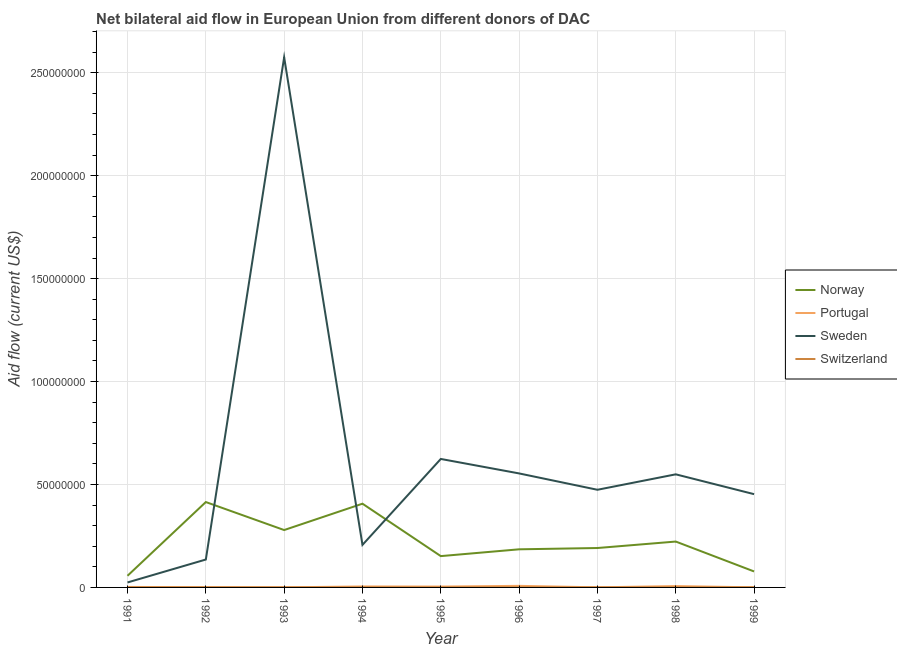Is the number of lines equal to the number of legend labels?
Offer a terse response. Yes. What is the amount of aid given by sweden in 1998?
Provide a short and direct response. 5.49e+07. Across all years, what is the maximum amount of aid given by switzerland?
Offer a terse response. 9.00e+04. Across all years, what is the minimum amount of aid given by norway?
Give a very brief answer. 5.65e+06. What is the total amount of aid given by sweden in the graph?
Your answer should be very brief. 5.60e+08. What is the difference between the amount of aid given by sweden in 1992 and that in 1993?
Provide a succinct answer. -2.44e+08. What is the difference between the amount of aid given by portugal in 1999 and the amount of aid given by norway in 1995?
Offer a very short reply. -1.52e+07. What is the average amount of aid given by portugal per year?
Offer a very short reply. 3.13e+05. In the year 1993, what is the difference between the amount of aid given by norway and amount of aid given by switzerland?
Offer a very short reply. 2.78e+07. In how many years, is the amount of aid given by switzerland greater than 170000000 US$?
Keep it short and to the point. 0. What is the ratio of the amount of aid given by switzerland in 1995 to that in 1998?
Make the answer very short. 0.57. Is the amount of aid given by norway in 1994 less than that in 1998?
Your response must be concise. No. What is the difference between the highest and the second highest amount of aid given by switzerland?
Offer a very short reply. 2.00e+04. What is the difference between the highest and the lowest amount of aid given by switzerland?
Ensure brevity in your answer.  5.00e+04. In how many years, is the amount of aid given by norway greater than the average amount of aid given by norway taken over all years?
Ensure brevity in your answer.  4. Does the amount of aid given by norway monotonically increase over the years?
Provide a short and direct response. No. How many lines are there?
Offer a very short reply. 4. What is the difference between two consecutive major ticks on the Y-axis?
Keep it short and to the point. 5.00e+07. Are the values on the major ticks of Y-axis written in scientific E-notation?
Provide a succinct answer. No. Does the graph contain any zero values?
Provide a succinct answer. No. How many legend labels are there?
Your answer should be very brief. 4. What is the title of the graph?
Your response must be concise. Net bilateral aid flow in European Union from different donors of DAC. What is the Aid flow (current US$) in Norway in 1991?
Make the answer very short. 5.65e+06. What is the Aid flow (current US$) of Portugal in 1991?
Offer a terse response. 2.40e+05. What is the Aid flow (current US$) in Sweden in 1991?
Provide a succinct answer. 2.41e+06. What is the Aid flow (current US$) in Switzerland in 1991?
Your response must be concise. 7.00e+04. What is the Aid flow (current US$) in Norway in 1992?
Give a very brief answer. 4.15e+07. What is the Aid flow (current US$) of Sweden in 1992?
Make the answer very short. 1.36e+07. What is the Aid flow (current US$) in Norway in 1993?
Offer a very short reply. 2.79e+07. What is the Aid flow (current US$) of Sweden in 1993?
Offer a very short reply. 2.57e+08. What is the Aid flow (current US$) in Switzerland in 1993?
Offer a very short reply. 6.00e+04. What is the Aid flow (current US$) in Norway in 1994?
Provide a short and direct response. 4.07e+07. What is the Aid flow (current US$) in Sweden in 1994?
Keep it short and to the point. 2.07e+07. What is the Aid flow (current US$) in Norway in 1995?
Provide a succinct answer. 1.52e+07. What is the Aid flow (current US$) in Portugal in 1995?
Give a very brief answer. 4.20e+05. What is the Aid flow (current US$) in Sweden in 1995?
Your answer should be compact. 6.24e+07. What is the Aid flow (current US$) in Switzerland in 1995?
Your response must be concise. 4.00e+04. What is the Aid flow (current US$) of Norway in 1996?
Your answer should be compact. 1.85e+07. What is the Aid flow (current US$) of Portugal in 1996?
Your answer should be very brief. 7.70e+05. What is the Aid flow (current US$) of Sweden in 1996?
Offer a terse response. 5.54e+07. What is the Aid flow (current US$) in Norway in 1997?
Offer a terse response. 1.91e+07. What is the Aid flow (current US$) in Sweden in 1997?
Provide a short and direct response. 4.74e+07. What is the Aid flow (current US$) of Norway in 1998?
Provide a succinct answer. 2.23e+07. What is the Aid flow (current US$) of Portugal in 1998?
Keep it short and to the point. 6.60e+05. What is the Aid flow (current US$) in Sweden in 1998?
Offer a terse response. 5.49e+07. What is the Aid flow (current US$) in Switzerland in 1998?
Your answer should be compact. 7.00e+04. What is the Aid flow (current US$) in Norway in 1999?
Give a very brief answer. 7.76e+06. What is the Aid flow (current US$) of Sweden in 1999?
Your answer should be very brief. 4.53e+07. Across all years, what is the maximum Aid flow (current US$) in Norway?
Offer a terse response. 4.15e+07. Across all years, what is the maximum Aid flow (current US$) in Portugal?
Provide a short and direct response. 7.70e+05. Across all years, what is the maximum Aid flow (current US$) in Sweden?
Give a very brief answer. 2.57e+08. Across all years, what is the minimum Aid flow (current US$) of Norway?
Your answer should be compact. 5.65e+06. Across all years, what is the minimum Aid flow (current US$) of Portugal?
Your answer should be very brief. 4.00e+04. Across all years, what is the minimum Aid flow (current US$) in Sweden?
Your answer should be compact. 2.41e+06. Across all years, what is the minimum Aid flow (current US$) of Switzerland?
Offer a very short reply. 4.00e+04. What is the total Aid flow (current US$) of Norway in the graph?
Your response must be concise. 1.99e+08. What is the total Aid flow (current US$) of Portugal in the graph?
Give a very brief answer. 2.82e+06. What is the total Aid flow (current US$) of Sweden in the graph?
Offer a very short reply. 5.60e+08. What is the total Aid flow (current US$) in Switzerland in the graph?
Your response must be concise. 5.70e+05. What is the difference between the Aid flow (current US$) of Norway in 1991 and that in 1992?
Your response must be concise. -3.58e+07. What is the difference between the Aid flow (current US$) in Portugal in 1991 and that in 1992?
Your answer should be very brief. 1.20e+05. What is the difference between the Aid flow (current US$) of Sweden in 1991 and that in 1992?
Give a very brief answer. -1.11e+07. What is the difference between the Aid flow (current US$) in Switzerland in 1991 and that in 1992?
Your answer should be compact. 0. What is the difference between the Aid flow (current US$) of Norway in 1991 and that in 1993?
Make the answer very short. -2.22e+07. What is the difference between the Aid flow (current US$) in Sweden in 1991 and that in 1993?
Offer a very short reply. -2.55e+08. What is the difference between the Aid flow (current US$) in Norway in 1991 and that in 1994?
Your answer should be compact. -3.50e+07. What is the difference between the Aid flow (current US$) of Portugal in 1991 and that in 1994?
Your response must be concise. -2.30e+05. What is the difference between the Aid flow (current US$) of Sweden in 1991 and that in 1994?
Your answer should be compact. -1.82e+07. What is the difference between the Aid flow (current US$) in Switzerland in 1991 and that in 1994?
Provide a short and direct response. 2.00e+04. What is the difference between the Aid flow (current US$) of Norway in 1991 and that in 1995?
Make the answer very short. -9.56e+06. What is the difference between the Aid flow (current US$) of Portugal in 1991 and that in 1995?
Your answer should be very brief. -1.80e+05. What is the difference between the Aid flow (current US$) in Sweden in 1991 and that in 1995?
Make the answer very short. -6.00e+07. What is the difference between the Aid flow (current US$) in Switzerland in 1991 and that in 1995?
Your answer should be very brief. 3.00e+04. What is the difference between the Aid flow (current US$) in Norway in 1991 and that in 1996?
Ensure brevity in your answer.  -1.29e+07. What is the difference between the Aid flow (current US$) in Portugal in 1991 and that in 1996?
Provide a succinct answer. -5.30e+05. What is the difference between the Aid flow (current US$) of Sweden in 1991 and that in 1996?
Your answer should be compact. -5.30e+07. What is the difference between the Aid flow (current US$) in Norway in 1991 and that in 1997?
Ensure brevity in your answer.  -1.35e+07. What is the difference between the Aid flow (current US$) in Portugal in 1991 and that in 1997?
Provide a succinct answer. 1.90e+05. What is the difference between the Aid flow (current US$) of Sweden in 1991 and that in 1997?
Ensure brevity in your answer.  -4.50e+07. What is the difference between the Aid flow (current US$) in Switzerland in 1991 and that in 1997?
Provide a short and direct response. 10000. What is the difference between the Aid flow (current US$) in Norway in 1991 and that in 1998?
Give a very brief answer. -1.66e+07. What is the difference between the Aid flow (current US$) of Portugal in 1991 and that in 1998?
Make the answer very short. -4.20e+05. What is the difference between the Aid flow (current US$) in Sweden in 1991 and that in 1998?
Offer a very short reply. -5.25e+07. What is the difference between the Aid flow (current US$) of Norway in 1991 and that in 1999?
Provide a succinct answer. -2.11e+06. What is the difference between the Aid flow (current US$) in Sweden in 1991 and that in 1999?
Offer a terse response. -4.29e+07. What is the difference between the Aid flow (current US$) of Norway in 1992 and that in 1993?
Your response must be concise. 1.36e+07. What is the difference between the Aid flow (current US$) in Sweden in 1992 and that in 1993?
Offer a very short reply. -2.44e+08. What is the difference between the Aid flow (current US$) of Switzerland in 1992 and that in 1993?
Offer a very short reply. 10000. What is the difference between the Aid flow (current US$) of Portugal in 1992 and that in 1994?
Keep it short and to the point. -3.50e+05. What is the difference between the Aid flow (current US$) of Sweden in 1992 and that in 1994?
Provide a succinct answer. -7.11e+06. What is the difference between the Aid flow (current US$) of Switzerland in 1992 and that in 1994?
Your answer should be very brief. 2.00e+04. What is the difference between the Aid flow (current US$) of Norway in 1992 and that in 1995?
Offer a very short reply. 2.63e+07. What is the difference between the Aid flow (current US$) of Sweden in 1992 and that in 1995?
Offer a terse response. -4.88e+07. What is the difference between the Aid flow (current US$) of Switzerland in 1992 and that in 1995?
Your response must be concise. 3.00e+04. What is the difference between the Aid flow (current US$) of Norway in 1992 and that in 1996?
Keep it short and to the point. 2.30e+07. What is the difference between the Aid flow (current US$) of Portugal in 1992 and that in 1996?
Ensure brevity in your answer.  -6.50e+05. What is the difference between the Aid flow (current US$) of Sweden in 1992 and that in 1996?
Your answer should be very brief. -4.18e+07. What is the difference between the Aid flow (current US$) in Norway in 1992 and that in 1997?
Keep it short and to the point. 2.23e+07. What is the difference between the Aid flow (current US$) in Sweden in 1992 and that in 1997?
Ensure brevity in your answer.  -3.39e+07. What is the difference between the Aid flow (current US$) in Switzerland in 1992 and that in 1997?
Provide a short and direct response. 10000. What is the difference between the Aid flow (current US$) in Norway in 1992 and that in 1998?
Provide a short and direct response. 1.92e+07. What is the difference between the Aid flow (current US$) in Portugal in 1992 and that in 1998?
Your response must be concise. -5.40e+05. What is the difference between the Aid flow (current US$) in Sweden in 1992 and that in 1998?
Offer a terse response. -4.14e+07. What is the difference between the Aid flow (current US$) of Switzerland in 1992 and that in 1998?
Offer a very short reply. 0. What is the difference between the Aid flow (current US$) in Norway in 1992 and that in 1999?
Ensure brevity in your answer.  3.37e+07. What is the difference between the Aid flow (current US$) of Portugal in 1992 and that in 1999?
Make the answer very short. 7.00e+04. What is the difference between the Aid flow (current US$) in Sweden in 1992 and that in 1999?
Your answer should be compact. -3.18e+07. What is the difference between the Aid flow (current US$) in Switzerland in 1992 and that in 1999?
Provide a succinct answer. -2.00e+04. What is the difference between the Aid flow (current US$) in Norway in 1993 and that in 1994?
Your answer should be compact. -1.28e+07. What is the difference between the Aid flow (current US$) of Portugal in 1993 and that in 1994?
Provide a short and direct response. -4.30e+05. What is the difference between the Aid flow (current US$) of Sweden in 1993 and that in 1994?
Your answer should be compact. 2.37e+08. What is the difference between the Aid flow (current US$) of Norway in 1993 and that in 1995?
Keep it short and to the point. 1.27e+07. What is the difference between the Aid flow (current US$) of Portugal in 1993 and that in 1995?
Provide a short and direct response. -3.80e+05. What is the difference between the Aid flow (current US$) of Sweden in 1993 and that in 1995?
Keep it short and to the point. 1.95e+08. What is the difference between the Aid flow (current US$) of Switzerland in 1993 and that in 1995?
Provide a succinct answer. 2.00e+04. What is the difference between the Aid flow (current US$) in Norway in 1993 and that in 1996?
Your answer should be compact. 9.36e+06. What is the difference between the Aid flow (current US$) in Portugal in 1993 and that in 1996?
Offer a very short reply. -7.30e+05. What is the difference between the Aid flow (current US$) in Sweden in 1993 and that in 1996?
Keep it short and to the point. 2.02e+08. What is the difference between the Aid flow (current US$) in Norway in 1993 and that in 1997?
Your answer should be compact. 8.73e+06. What is the difference between the Aid flow (current US$) in Sweden in 1993 and that in 1997?
Give a very brief answer. 2.10e+08. What is the difference between the Aid flow (current US$) of Switzerland in 1993 and that in 1997?
Give a very brief answer. 0. What is the difference between the Aid flow (current US$) in Norway in 1993 and that in 1998?
Your answer should be very brief. 5.59e+06. What is the difference between the Aid flow (current US$) in Portugal in 1993 and that in 1998?
Your answer should be very brief. -6.20e+05. What is the difference between the Aid flow (current US$) in Sweden in 1993 and that in 1998?
Your answer should be compact. 2.03e+08. What is the difference between the Aid flow (current US$) of Norway in 1993 and that in 1999?
Give a very brief answer. 2.01e+07. What is the difference between the Aid flow (current US$) in Sweden in 1993 and that in 1999?
Offer a very short reply. 2.12e+08. What is the difference between the Aid flow (current US$) of Norway in 1994 and that in 1995?
Offer a very short reply. 2.55e+07. What is the difference between the Aid flow (current US$) of Sweden in 1994 and that in 1995?
Keep it short and to the point. -4.17e+07. What is the difference between the Aid flow (current US$) of Switzerland in 1994 and that in 1995?
Offer a very short reply. 10000. What is the difference between the Aid flow (current US$) of Norway in 1994 and that in 1996?
Ensure brevity in your answer.  2.22e+07. What is the difference between the Aid flow (current US$) of Portugal in 1994 and that in 1996?
Give a very brief answer. -3.00e+05. What is the difference between the Aid flow (current US$) of Sweden in 1994 and that in 1996?
Give a very brief answer. -3.47e+07. What is the difference between the Aid flow (current US$) of Norway in 1994 and that in 1997?
Make the answer very short. 2.15e+07. What is the difference between the Aid flow (current US$) of Sweden in 1994 and that in 1997?
Make the answer very short. -2.68e+07. What is the difference between the Aid flow (current US$) of Norway in 1994 and that in 1998?
Offer a terse response. 1.84e+07. What is the difference between the Aid flow (current US$) of Portugal in 1994 and that in 1998?
Provide a short and direct response. -1.90e+05. What is the difference between the Aid flow (current US$) in Sweden in 1994 and that in 1998?
Offer a terse response. -3.43e+07. What is the difference between the Aid flow (current US$) of Norway in 1994 and that in 1999?
Your response must be concise. 3.29e+07. What is the difference between the Aid flow (current US$) of Sweden in 1994 and that in 1999?
Provide a short and direct response. -2.46e+07. What is the difference between the Aid flow (current US$) in Switzerland in 1994 and that in 1999?
Provide a succinct answer. -4.00e+04. What is the difference between the Aid flow (current US$) in Norway in 1995 and that in 1996?
Offer a terse response. -3.30e+06. What is the difference between the Aid flow (current US$) of Portugal in 1995 and that in 1996?
Offer a very short reply. -3.50e+05. What is the difference between the Aid flow (current US$) of Sweden in 1995 and that in 1996?
Your answer should be compact. 7.03e+06. What is the difference between the Aid flow (current US$) of Switzerland in 1995 and that in 1996?
Keep it short and to the point. -2.00e+04. What is the difference between the Aid flow (current US$) in Norway in 1995 and that in 1997?
Keep it short and to the point. -3.93e+06. What is the difference between the Aid flow (current US$) in Sweden in 1995 and that in 1997?
Ensure brevity in your answer.  1.50e+07. What is the difference between the Aid flow (current US$) of Norway in 1995 and that in 1998?
Provide a succinct answer. -7.07e+06. What is the difference between the Aid flow (current US$) of Sweden in 1995 and that in 1998?
Give a very brief answer. 7.47e+06. What is the difference between the Aid flow (current US$) of Switzerland in 1995 and that in 1998?
Your answer should be very brief. -3.00e+04. What is the difference between the Aid flow (current US$) of Norway in 1995 and that in 1999?
Your answer should be compact. 7.45e+06. What is the difference between the Aid flow (current US$) of Sweden in 1995 and that in 1999?
Your answer should be compact. 1.71e+07. What is the difference between the Aid flow (current US$) of Switzerland in 1995 and that in 1999?
Keep it short and to the point. -5.00e+04. What is the difference between the Aid flow (current US$) in Norway in 1996 and that in 1997?
Your answer should be very brief. -6.30e+05. What is the difference between the Aid flow (current US$) in Portugal in 1996 and that in 1997?
Provide a succinct answer. 7.20e+05. What is the difference between the Aid flow (current US$) in Sweden in 1996 and that in 1997?
Give a very brief answer. 7.94e+06. What is the difference between the Aid flow (current US$) in Norway in 1996 and that in 1998?
Your answer should be compact. -3.77e+06. What is the difference between the Aid flow (current US$) in Portugal in 1996 and that in 1998?
Make the answer very short. 1.10e+05. What is the difference between the Aid flow (current US$) in Switzerland in 1996 and that in 1998?
Your answer should be very brief. -10000. What is the difference between the Aid flow (current US$) in Norway in 1996 and that in 1999?
Give a very brief answer. 1.08e+07. What is the difference between the Aid flow (current US$) of Portugal in 1996 and that in 1999?
Ensure brevity in your answer.  7.20e+05. What is the difference between the Aid flow (current US$) in Sweden in 1996 and that in 1999?
Offer a terse response. 1.01e+07. What is the difference between the Aid flow (current US$) of Switzerland in 1996 and that in 1999?
Make the answer very short. -3.00e+04. What is the difference between the Aid flow (current US$) of Norway in 1997 and that in 1998?
Provide a short and direct response. -3.14e+06. What is the difference between the Aid flow (current US$) in Portugal in 1997 and that in 1998?
Ensure brevity in your answer.  -6.10e+05. What is the difference between the Aid flow (current US$) of Sweden in 1997 and that in 1998?
Your answer should be very brief. -7.50e+06. What is the difference between the Aid flow (current US$) of Switzerland in 1997 and that in 1998?
Give a very brief answer. -10000. What is the difference between the Aid flow (current US$) of Norway in 1997 and that in 1999?
Keep it short and to the point. 1.14e+07. What is the difference between the Aid flow (current US$) of Portugal in 1997 and that in 1999?
Give a very brief answer. 0. What is the difference between the Aid flow (current US$) of Sweden in 1997 and that in 1999?
Your answer should be very brief. 2.13e+06. What is the difference between the Aid flow (current US$) in Switzerland in 1997 and that in 1999?
Give a very brief answer. -3.00e+04. What is the difference between the Aid flow (current US$) in Norway in 1998 and that in 1999?
Make the answer very short. 1.45e+07. What is the difference between the Aid flow (current US$) of Portugal in 1998 and that in 1999?
Offer a terse response. 6.10e+05. What is the difference between the Aid flow (current US$) of Sweden in 1998 and that in 1999?
Provide a succinct answer. 9.63e+06. What is the difference between the Aid flow (current US$) of Switzerland in 1998 and that in 1999?
Offer a very short reply. -2.00e+04. What is the difference between the Aid flow (current US$) of Norway in 1991 and the Aid flow (current US$) of Portugal in 1992?
Your answer should be compact. 5.53e+06. What is the difference between the Aid flow (current US$) of Norway in 1991 and the Aid flow (current US$) of Sweden in 1992?
Make the answer very short. -7.90e+06. What is the difference between the Aid flow (current US$) of Norway in 1991 and the Aid flow (current US$) of Switzerland in 1992?
Provide a short and direct response. 5.58e+06. What is the difference between the Aid flow (current US$) in Portugal in 1991 and the Aid flow (current US$) in Sweden in 1992?
Provide a short and direct response. -1.33e+07. What is the difference between the Aid flow (current US$) in Portugal in 1991 and the Aid flow (current US$) in Switzerland in 1992?
Offer a terse response. 1.70e+05. What is the difference between the Aid flow (current US$) of Sweden in 1991 and the Aid flow (current US$) of Switzerland in 1992?
Make the answer very short. 2.34e+06. What is the difference between the Aid flow (current US$) in Norway in 1991 and the Aid flow (current US$) in Portugal in 1993?
Your answer should be compact. 5.61e+06. What is the difference between the Aid flow (current US$) of Norway in 1991 and the Aid flow (current US$) of Sweden in 1993?
Keep it short and to the point. -2.52e+08. What is the difference between the Aid flow (current US$) in Norway in 1991 and the Aid flow (current US$) in Switzerland in 1993?
Keep it short and to the point. 5.59e+06. What is the difference between the Aid flow (current US$) of Portugal in 1991 and the Aid flow (current US$) of Sweden in 1993?
Provide a succinct answer. -2.57e+08. What is the difference between the Aid flow (current US$) of Sweden in 1991 and the Aid flow (current US$) of Switzerland in 1993?
Your response must be concise. 2.35e+06. What is the difference between the Aid flow (current US$) of Norway in 1991 and the Aid flow (current US$) of Portugal in 1994?
Make the answer very short. 5.18e+06. What is the difference between the Aid flow (current US$) of Norway in 1991 and the Aid flow (current US$) of Sweden in 1994?
Provide a succinct answer. -1.50e+07. What is the difference between the Aid flow (current US$) in Norway in 1991 and the Aid flow (current US$) in Switzerland in 1994?
Ensure brevity in your answer.  5.60e+06. What is the difference between the Aid flow (current US$) in Portugal in 1991 and the Aid flow (current US$) in Sweden in 1994?
Make the answer very short. -2.04e+07. What is the difference between the Aid flow (current US$) in Sweden in 1991 and the Aid flow (current US$) in Switzerland in 1994?
Your response must be concise. 2.36e+06. What is the difference between the Aid flow (current US$) of Norway in 1991 and the Aid flow (current US$) of Portugal in 1995?
Give a very brief answer. 5.23e+06. What is the difference between the Aid flow (current US$) of Norway in 1991 and the Aid flow (current US$) of Sweden in 1995?
Offer a very short reply. -5.68e+07. What is the difference between the Aid flow (current US$) in Norway in 1991 and the Aid flow (current US$) in Switzerland in 1995?
Offer a very short reply. 5.61e+06. What is the difference between the Aid flow (current US$) in Portugal in 1991 and the Aid flow (current US$) in Sweden in 1995?
Offer a terse response. -6.22e+07. What is the difference between the Aid flow (current US$) of Sweden in 1991 and the Aid flow (current US$) of Switzerland in 1995?
Offer a very short reply. 2.37e+06. What is the difference between the Aid flow (current US$) in Norway in 1991 and the Aid flow (current US$) in Portugal in 1996?
Make the answer very short. 4.88e+06. What is the difference between the Aid flow (current US$) of Norway in 1991 and the Aid flow (current US$) of Sweden in 1996?
Your answer should be very brief. -4.97e+07. What is the difference between the Aid flow (current US$) in Norway in 1991 and the Aid flow (current US$) in Switzerland in 1996?
Ensure brevity in your answer.  5.59e+06. What is the difference between the Aid flow (current US$) of Portugal in 1991 and the Aid flow (current US$) of Sweden in 1996?
Offer a very short reply. -5.51e+07. What is the difference between the Aid flow (current US$) of Portugal in 1991 and the Aid flow (current US$) of Switzerland in 1996?
Provide a succinct answer. 1.80e+05. What is the difference between the Aid flow (current US$) of Sweden in 1991 and the Aid flow (current US$) of Switzerland in 1996?
Offer a very short reply. 2.35e+06. What is the difference between the Aid flow (current US$) of Norway in 1991 and the Aid flow (current US$) of Portugal in 1997?
Offer a terse response. 5.60e+06. What is the difference between the Aid flow (current US$) of Norway in 1991 and the Aid flow (current US$) of Sweden in 1997?
Ensure brevity in your answer.  -4.18e+07. What is the difference between the Aid flow (current US$) in Norway in 1991 and the Aid flow (current US$) in Switzerland in 1997?
Your response must be concise. 5.59e+06. What is the difference between the Aid flow (current US$) of Portugal in 1991 and the Aid flow (current US$) of Sweden in 1997?
Offer a very short reply. -4.72e+07. What is the difference between the Aid flow (current US$) in Sweden in 1991 and the Aid flow (current US$) in Switzerland in 1997?
Offer a terse response. 2.35e+06. What is the difference between the Aid flow (current US$) of Norway in 1991 and the Aid flow (current US$) of Portugal in 1998?
Give a very brief answer. 4.99e+06. What is the difference between the Aid flow (current US$) in Norway in 1991 and the Aid flow (current US$) in Sweden in 1998?
Offer a terse response. -4.93e+07. What is the difference between the Aid flow (current US$) in Norway in 1991 and the Aid flow (current US$) in Switzerland in 1998?
Your answer should be very brief. 5.58e+06. What is the difference between the Aid flow (current US$) of Portugal in 1991 and the Aid flow (current US$) of Sweden in 1998?
Your answer should be compact. -5.47e+07. What is the difference between the Aid flow (current US$) in Sweden in 1991 and the Aid flow (current US$) in Switzerland in 1998?
Provide a short and direct response. 2.34e+06. What is the difference between the Aid flow (current US$) of Norway in 1991 and the Aid flow (current US$) of Portugal in 1999?
Your response must be concise. 5.60e+06. What is the difference between the Aid flow (current US$) in Norway in 1991 and the Aid flow (current US$) in Sweden in 1999?
Keep it short and to the point. -3.96e+07. What is the difference between the Aid flow (current US$) of Norway in 1991 and the Aid flow (current US$) of Switzerland in 1999?
Your response must be concise. 5.56e+06. What is the difference between the Aid flow (current US$) in Portugal in 1991 and the Aid flow (current US$) in Sweden in 1999?
Provide a short and direct response. -4.51e+07. What is the difference between the Aid flow (current US$) in Portugal in 1991 and the Aid flow (current US$) in Switzerland in 1999?
Ensure brevity in your answer.  1.50e+05. What is the difference between the Aid flow (current US$) of Sweden in 1991 and the Aid flow (current US$) of Switzerland in 1999?
Offer a terse response. 2.32e+06. What is the difference between the Aid flow (current US$) in Norway in 1992 and the Aid flow (current US$) in Portugal in 1993?
Your answer should be compact. 4.14e+07. What is the difference between the Aid flow (current US$) in Norway in 1992 and the Aid flow (current US$) in Sweden in 1993?
Keep it short and to the point. -2.16e+08. What is the difference between the Aid flow (current US$) of Norway in 1992 and the Aid flow (current US$) of Switzerland in 1993?
Your response must be concise. 4.14e+07. What is the difference between the Aid flow (current US$) of Portugal in 1992 and the Aid flow (current US$) of Sweden in 1993?
Provide a short and direct response. -2.57e+08. What is the difference between the Aid flow (current US$) in Portugal in 1992 and the Aid flow (current US$) in Switzerland in 1993?
Give a very brief answer. 6.00e+04. What is the difference between the Aid flow (current US$) in Sweden in 1992 and the Aid flow (current US$) in Switzerland in 1993?
Keep it short and to the point. 1.35e+07. What is the difference between the Aid flow (current US$) of Norway in 1992 and the Aid flow (current US$) of Portugal in 1994?
Offer a very short reply. 4.10e+07. What is the difference between the Aid flow (current US$) in Norway in 1992 and the Aid flow (current US$) in Sweden in 1994?
Offer a very short reply. 2.08e+07. What is the difference between the Aid flow (current US$) in Norway in 1992 and the Aid flow (current US$) in Switzerland in 1994?
Offer a very short reply. 4.14e+07. What is the difference between the Aid flow (current US$) in Portugal in 1992 and the Aid flow (current US$) in Sweden in 1994?
Keep it short and to the point. -2.05e+07. What is the difference between the Aid flow (current US$) in Sweden in 1992 and the Aid flow (current US$) in Switzerland in 1994?
Offer a very short reply. 1.35e+07. What is the difference between the Aid flow (current US$) of Norway in 1992 and the Aid flow (current US$) of Portugal in 1995?
Offer a very short reply. 4.10e+07. What is the difference between the Aid flow (current US$) in Norway in 1992 and the Aid flow (current US$) in Sweden in 1995?
Provide a succinct answer. -2.09e+07. What is the difference between the Aid flow (current US$) in Norway in 1992 and the Aid flow (current US$) in Switzerland in 1995?
Your response must be concise. 4.14e+07. What is the difference between the Aid flow (current US$) of Portugal in 1992 and the Aid flow (current US$) of Sweden in 1995?
Your answer should be compact. -6.23e+07. What is the difference between the Aid flow (current US$) of Portugal in 1992 and the Aid flow (current US$) of Switzerland in 1995?
Offer a terse response. 8.00e+04. What is the difference between the Aid flow (current US$) in Sweden in 1992 and the Aid flow (current US$) in Switzerland in 1995?
Offer a terse response. 1.35e+07. What is the difference between the Aid flow (current US$) of Norway in 1992 and the Aid flow (current US$) of Portugal in 1996?
Your response must be concise. 4.07e+07. What is the difference between the Aid flow (current US$) of Norway in 1992 and the Aid flow (current US$) of Sweden in 1996?
Provide a succinct answer. -1.39e+07. What is the difference between the Aid flow (current US$) in Norway in 1992 and the Aid flow (current US$) in Switzerland in 1996?
Provide a short and direct response. 4.14e+07. What is the difference between the Aid flow (current US$) in Portugal in 1992 and the Aid flow (current US$) in Sweden in 1996?
Offer a terse response. -5.52e+07. What is the difference between the Aid flow (current US$) in Portugal in 1992 and the Aid flow (current US$) in Switzerland in 1996?
Offer a terse response. 6.00e+04. What is the difference between the Aid flow (current US$) in Sweden in 1992 and the Aid flow (current US$) in Switzerland in 1996?
Your answer should be compact. 1.35e+07. What is the difference between the Aid flow (current US$) of Norway in 1992 and the Aid flow (current US$) of Portugal in 1997?
Offer a very short reply. 4.14e+07. What is the difference between the Aid flow (current US$) in Norway in 1992 and the Aid flow (current US$) in Sweden in 1997?
Keep it short and to the point. -5.96e+06. What is the difference between the Aid flow (current US$) of Norway in 1992 and the Aid flow (current US$) of Switzerland in 1997?
Make the answer very short. 4.14e+07. What is the difference between the Aid flow (current US$) of Portugal in 1992 and the Aid flow (current US$) of Sweden in 1997?
Offer a very short reply. -4.73e+07. What is the difference between the Aid flow (current US$) in Portugal in 1992 and the Aid flow (current US$) in Switzerland in 1997?
Provide a succinct answer. 6.00e+04. What is the difference between the Aid flow (current US$) of Sweden in 1992 and the Aid flow (current US$) of Switzerland in 1997?
Give a very brief answer. 1.35e+07. What is the difference between the Aid flow (current US$) of Norway in 1992 and the Aid flow (current US$) of Portugal in 1998?
Offer a very short reply. 4.08e+07. What is the difference between the Aid flow (current US$) in Norway in 1992 and the Aid flow (current US$) in Sweden in 1998?
Make the answer very short. -1.35e+07. What is the difference between the Aid flow (current US$) of Norway in 1992 and the Aid flow (current US$) of Switzerland in 1998?
Offer a terse response. 4.14e+07. What is the difference between the Aid flow (current US$) of Portugal in 1992 and the Aid flow (current US$) of Sweden in 1998?
Your answer should be compact. -5.48e+07. What is the difference between the Aid flow (current US$) of Sweden in 1992 and the Aid flow (current US$) of Switzerland in 1998?
Keep it short and to the point. 1.35e+07. What is the difference between the Aid flow (current US$) of Norway in 1992 and the Aid flow (current US$) of Portugal in 1999?
Provide a short and direct response. 4.14e+07. What is the difference between the Aid flow (current US$) of Norway in 1992 and the Aid flow (current US$) of Sweden in 1999?
Provide a succinct answer. -3.83e+06. What is the difference between the Aid flow (current US$) of Norway in 1992 and the Aid flow (current US$) of Switzerland in 1999?
Provide a short and direct response. 4.14e+07. What is the difference between the Aid flow (current US$) of Portugal in 1992 and the Aid flow (current US$) of Sweden in 1999?
Provide a short and direct response. -4.52e+07. What is the difference between the Aid flow (current US$) of Sweden in 1992 and the Aid flow (current US$) of Switzerland in 1999?
Your answer should be compact. 1.35e+07. What is the difference between the Aid flow (current US$) of Norway in 1993 and the Aid flow (current US$) of Portugal in 1994?
Make the answer very short. 2.74e+07. What is the difference between the Aid flow (current US$) in Norway in 1993 and the Aid flow (current US$) in Sweden in 1994?
Offer a very short reply. 7.21e+06. What is the difference between the Aid flow (current US$) in Norway in 1993 and the Aid flow (current US$) in Switzerland in 1994?
Offer a very short reply. 2.78e+07. What is the difference between the Aid flow (current US$) in Portugal in 1993 and the Aid flow (current US$) in Sweden in 1994?
Offer a very short reply. -2.06e+07. What is the difference between the Aid flow (current US$) of Portugal in 1993 and the Aid flow (current US$) of Switzerland in 1994?
Your response must be concise. -10000. What is the difference between the Aid flow (current US$) in Sweden in 1993 and the Aid flow (current US$) in Switzerland in 1994?
Provide a short and direct response. 2.57e+08. What is the difference between the Aid flow (current US$) of Norway in 1993 and the Aid flow (current US$) of Portugal in 1995?
Make the answer very short. 2.74e+07. What is the difference between the Aid flow (current US$) of Norway in 1993 and the Aid flow (current US$) of Sweden in 1995?
Provide a succinct answer. -3.45e+07. What is the difference between the Aid flow (current US$) in Norway in 1993 and the Aid flow (current US$) in Switzerland in 1995?
Give a very brief answer. 2.78e+07. What is the difference between the Aid flow (current US$) of Portugal in 1993 and the Aid flow (current US$) of Sweden in 1995?
Ensure brevity in your answer.  -6.24e+07. What is the difference between the Aid flow (current US$) in Portugal in 1993 and the Aid flow (current US$) in Switzerland in 1995?
Your response must be concise. 0. What is the difference between the Aid flow (current US$) in Sweden in 1993 and the Aid flow (current US$) in Switzerland in 1995?
Provide a succinct answer. 2.57e+08. What is the difference between the Aid flow (current US$) of Norway in 1993 and the Aid flow (current US$) of Portugal in 1996?
Provide a succinct answer. 2.71e+07. What is the difference between the Aid flow (current US$) of Norway in 1993 and the Aid flow (current US$) of Sweden in 1996?
Your answer should be compact. -2.75e+07. What is the difference between the Aid flow (current US$) in Norway in 1993 and the Aid flow (current US$) in Switzerland in 1996?
Ensure brevity in your answer.  2.78e+07. What is the difference between the Aid flow (current US$) in Portugal in 1993 and the Aid flow (current US$) in Sweden in 1996?
Give a very brief answer. -5.53e+07. What is the difference between the Aid flow (current US$) in Portugal in 1993 and the Aid flow (current US$) in Switzerland in 1996?
Your answer should be very brief. -2.00e+04. What is the difference between the Aid flow (current US$) in Sweden in 1993 and the Aid flow (current US$) in Switzerland in 1996?
Keep it short and to the point. 2.57e+08. What is the difference between the Aid flow (current US$) in Norway in 1993 and the Aid flow (current US$) in Portugal in 1997?
Ensure brevity in your answer.  2.78e+07. What is the difference between the Aid flow (current US$) of Norway in 1993 and the Aid flow (current US$) of Sweden in 1997?
Your answer should be very brief. -1.96e+07. What is the difference between the Aid flow (current US$) in Norway in 1993 and the Aid flow (current US$) in Switzerland in 1997?
Offer a very short reply. 2.78e+07. What is the difference between the Aid flow (current US$) in Portugal in 1993 and the Aid flow (current US$) in Sweden in 1997?
Offer a very short reply. -4.74e+07. What is the difference between the Aid flow (current US$) of Sweden in 1993 and the Aid flow (current US$) of Switzerland in 1997?
Make the answer very short. 2.57e+08. What is the difference between the Aid flow (current US$) of Norway in 1993 and the Aid flow (current US$) of Portugal in 1998?
Provide a short and direct response. 2.72e+07. What is the difference between the Aid flow (current US$) of Norway in 1993 and the Aid flow (current US$) of Sweden in 1998?
Offer a very short reply. -2.71e+07. What is the difference between the Aid flow (current US$) of Norway in 1993 and the Aid flow (current US$) of Switzerland in 1998?
Give a very brief answer. 2.78e+07. What is the difference between the Aid flow (current US$) in Portugal in 1993 and the Aid flow (current US$) in Sweden in 1998?
Keep it short and to the point. -5.49e+07. What is the difference between the Aid flow (current US$) of Portugal in 1993 and the Aid flow (current US$) of Switzerland in 1998?
Your response must be concise. -3.00e+04. What is the difference between the Aid flow (current US$) in Sweden in 1993 and the Aid flow (current US$) in Switzerland in 1998?
Offer a very short reply. 2.57e+08. What is the difference between the Aid flow (current US$) of Norway in 1993 and the Aid flow (current US$) of Portugal in 1999?
Your answer should be very brief. 2.78e+07. What is the difference between the Aid flow (current US$) of Norway in 1993 and the Aid flow (current US$) of Sweden in 1999?
Offer a terse response. -1.74e+07. What is the difference between the Aid flow (current US$) of Norway in 1993 and the Aid flow (current US$) of Switzerland in 1999?
Provide a short and direct response. 2.78e+07. What is the difference between the Aid flow (current US$) of Portugal in 1993 and the Aid flow (current US$) of Sweden in 1999?
Your answer should be compact. -4.53e+07. What is the difference between the Aid flow (current US$) of Sweden in 1993 and the Aid flow (current US$) of Switzerland in 1999?
Ensure brevity in your answer.  2.57e+08. What is the difference between the Aid flow (current US$) of Norway in 1994 and the Aid flow (current US$) of Portugal in 1995?
Ensure brevity in your answer.  4.02e+07. What is the difference between the Aid flow (current US$) of Norway in 1994 and the Aid flow (current US$) of Sweden in 1995?
Keep it short and to the point. -2.17e+07. What is the difference between the Aid flow (current US$) of Norway in 1994 and the Aid flow (current US$) of Switzerland in 1995?
Your response must be concise. 4.06e+07. What is the difference between the Aid flow (current US$) in Portugal in 1994 and the Aid flow (current US$) in Sweden in 1995?
Your response must be concise. -6.19e+07. What is the difference between the Aid flow (current US$) in Sweden in 1994 and the Aid flow (current US$) in Switzerland in 1995?
Your response must be concise. 2.06e+07. What is the difference between the Aid flow (current US$) of Norway in 1994 and the Aid flow (current US$) of Portugal in 1996?
Provide a short and direct response. 3.99e+07. What is the difference between the Aid flow (current US$) of Norway in 1994 and the Aid flow (current US$) of Sweden in 1996?
Give a very brief answer. -1.47e+07. What is the difference between the Aid flow (current US$) in Norway in 1994 and the Aid flow (current US$) in Switzerland in 1996?
Provide a succinct answer. 4.06e+07. What is the difference between the Aid flow (current US$) in Portugal in 1994 and the Aid flow (current US$) in Sweden in 1996?
Offer a terse response. -5.49e+07. What is the difference between the Aid flow (current US$) in Sweden in 1994 and the Aid flow (current US$) in Switzerland in 1996?
Keep it short and to the point. 2.06e+07. What is the difference between the Aid flow (current US$) in Norway in 1994 and the Aid flow (current US$) in Portugal in 1997?
Your response must be concise. 4.06e+07. What is the difference between the Aid flow (current US$) of Norway in 1994 and the Aid flow (current US$) of Sweden in 1997?
Provide a succinct answer. -6.76e+06. What is the difference between the Aid flow (current US$) in Norway in 1994 and the Aid flow (current US$) in Switzerland in 1997?
Make the answer very short. 4.06e+07. What is the difference between the Aid flow (current US$) in Portugal in 1994 and the Aid flow (current US$) in Sweden in 1997?
Offer a very short reply. -4.70e+07. What is the difference between the Aid flow (current US$) of Sweden in 1994 and the Aid flow (current US$) of Switzerland in 1997?
Your answer should be compact. 2.06e+07. What is the difference between the Aid flow (current US$) of Norway in 1994 and the Aid flow (current US$) of Portugal in 1998?
Your answer should be very brief. 4.00e+07. What is the difference between the Aid flow (current US$) of Norway in 1994 and the Aid flow (current US$) of Sweden in 1998?
Give a very brief answer. -1.43e+07. What is the difference between the Aid flow (current US$) of Norway in 1994 and the Aid flow (current US$) of Switzerland in 1998?
Offer a terse response. 4.06e+07. What is the difference between the Aid flow (current US$) of Portugal in 1994 and the Aid flow (current US$) of Sweden in 1998?
Your answer should be compact. -5.45e+07. What is the difference between the Aid flow (current US$) in Portugal in 1994 and the Aid flow (current US$) in Switzerland in 1998?
Your answer should be very brief. 4.00e+05. What is the difference between the Aid flow (current US$) in Sweden in 1994 and the Aid flow (current US$) in Switzerland in 1998?
Keep it short and to the point. 2.06e+07. What is the difference between the Aid flow (current US$) in Norway in 1994 and the Aid flow (current US$) in Portugal in 1999?
Give a very brief answer. 4.06e+07. What is the difference between the Aid flow (current US$) of Norway in 1994 and the Aid flow (current US$) of Sweden in 1999?
Offer a very short reply. -4.63e+06. What is the difference between the Aid flow (current US$) in Norway in 1994 and the Aid flow (current US$) in Switzerland in 1999?
Offer a terse response. 4.06e+07. What is the difference between the Aid flow (current US$) of Portugal in 1994 and the Aid flow (current US$) of Sweden in 1999?
Provide a short and direct response. -4.48e+07. What is the difference between the Aid flow (current US$) in Portugal in 1994 and the Aid flow (current US$) in Switzerland in 1999?
Your response must be concise. 3.80e+05. What is the difference between the Aid flow (current US$) of Sweden in 1994 and the Aid flow (current US$) of Switzerland in 1999?
Your response must be concise. 2.06e+07. What is the difference between the Aid flow (current US$) of Norway in 1995 and the Aid flow (current US$) of Portugal in 1996?
Provide a short and direct response. 1.44e+07. What is the difference between the Aid flow (current US$) of Norway in 1995 and the Aid flow (current US$) of Sweden in 1996?
Your answer should be very brief. -4.02e+07. What is the difference between the Aid flow (current US$) of Norway in 1995 and the Aid flow (current US$) of Switzerland in 1996?
Give a very brief answer. 1.52e+07. What is the difference between the Aid flow (current US$) in Portugal in 1995 and the Aid flow (current US$) in Sweden in 1996?
Keep it short and to the point. -5.50e+07. What is the difference between the Aid flow (current US$) of Portugal in 1995 and the Aid flow (current US$) of Switzerland in 1996?
Offer a terse response. 3.60e+05. What is the difference between the Aid flow (current US$) in Sweden in 1995 and the Aid flow (current US$) in Switzerland in 1996?
Ensure brevity in your answer.  6.23e+07. What is the difference between the Aid flow (current US$) of Norway in 1995 and the Aid flow (current US$) of Portugal in 1997?
Your answer should be compact. 1.52e+07. What is the difference between the Aid flow (current US$) of Norway in 1995 and the Aid flow (current US$) of Sweden in 1997?
Provide a short and direct response. -3.22e+07. What is the difference between the Aid flow (current US$) in Norway in 1995 and the Aid flow (current US$) in Switzerland in 1997?
Make the answer very short. 1.52e+07. What is the difference between the Aid flow (current US$) in Portugal in 1995 and the Aid flow (current US$) in Sweden in 1997?
Provide a short and direct response. -4.70e+07. What is the difference between the Aid flow (current US$) in Sweden in 1995 and the Aid flow (current US$) in Switzerland in 1997?
Make the answer very short. 6.23e+07. What is the difference between the Aid flow (current US$) in Norway in 1995 and the Aid flow (current US$) in Portugal in 1998?
Your answer should be compact. 1.46e+07. What is the difference between the Aid flow (current US$) in Norway in 1995 and the Aid flow (current US$) in Sweden in 1998?
Your response must be concise. -3.97e+07. What is the difference between the Aid flow (current US$) in Norway in 1995 and the Aid flow (current US$) in Switzerland in 1998?
Give a very brief answer. 1.51e+07. What is the difference between the Aid flow (current US$) of Portugal in 1995 and the Aid flow (current US$) of Sweden in 1998?
Your response must be concise. -5.45e+07. What is the difference between the Aid flow (current US$) of Portugal in 1995 and the Aid flow (current US$) of Switzerland in 1998?
Give a very brief answer. 3.50e+05. What is the difference between the Aid flow (current US$) in Sweden in 1995 and the Aid flow (current US$) in Switzerland in 1998?
Make the answer very short. 6.23e+07. What is the difference between the Aid flow (current US$) in Norway in 1995 and the Aid flow (current US$) in Portugal in 1999?
Offer a very short reply. 1.52e+07. What is the difference between the Aid flow (current US$) in Norway in 1995 and the Aid flow (current US$) in Sweden in 1999?
Your answer should be compact. -3.01e+07. What is the difference between the Aid flow (current US$) of Norway in 1995 and the Aid flow (current US$) of Switzerland in 1999?
Provide a short and direct response. 1.51e+07. What is the difference between the Aid flow (current US$) of Portugal in 1995 and the Aid flow (current US$) of Sweden in 1999?
Your answer should be very brief. -4.49e+07. What is the difference between the Aid flow (current US$) of Portugal in 1995 and the Aid flow (current US$) of Switzerland in 1999?
Provide a succinct answer. 3.30e+05. What is the difference between the Aid flow (current US$) of Sweden in 1995 and the Aid flow (current US$) of Switzerland in 1999?
Your answer should be compact. 6.23e+07. What is the difference between the Aid flow (current US$) of Norway in 1996 and the Aid flow (current US$) of Portugal in 1997?
Make the answer very short. 1.85e+07. What is the difference between the Aid flow (current US$) of Norway in 1996 and the Aid flow (current US$) of Sweden in 1997?
Your answer should be compact. -2.89e+07. What is the difference between the Aid flow (current US$) of Norway in 1996 and the Aid flow (current US$) of Switzerland in 1997?
Give a very brief answer. 1.84e+07. What is the difference between the Aid flow (current US$) in Portugal in 1996 and the Aid flow (current US$) in Sweden in 1997?
Give a very brief answer. -4.67e+07. What is the difference between the Aid flow (current US$) of Portugal in 1996 and the Aid flow (current US$) of Switzerland in 1997?
Keep it short and to the point. 7.10e+05. What is the difference between the Aid flow (current US$) in Sweden in 1996 and the Aid flow (current US$) in Switzerland in 1997?
Ensure brevity in your answer.  5.53e+07. What is the difference between the Aid flow (current US$) of Norway in 1996 and the Aid flow (current US$) of Portugal in 1998?
Ensure brevity in your answer.  1.78e+07. What is the difference between the Aid flow (current US$) of Norway in 1996 and the Aid flow (current US$) of Sweden in 1998?
Ensure brevity in your answer.  -3.64e+07. What is the difference between the Aid flow (current US$) in Norway in 1996 and the Aid flow (current US$) in Switzerland in 1998?
Provide a succinct answer. 1.84e+07. What is the difference between the Aid flow (current US$) in Portugal in 1996 and the Aid flow (current US$) in Sweden in 1998?
Your response must be concise. -5.42e+07. What is the difference between the Aid flow (current US$) of Portugal in 1996 and the Aid flow (current US$) of Switzerland in 1998?
Give a very brief answer. 7.00e+05. What is the difference between the Aid flow (current US$) in Sweden in 1996 and the Aid flow (current US$) in Switzerland in 1998?
Make the answer very short. 5.53e+07. What is the difference between the Aid flow (current US$) in Norway in 1996 and the Aid flow (current US$) in Portugal in 1999?
Give a very brief answer. 1.85e+07. What is the difference between the Aid flow (current US$) in Norway in 1996 and the Aid flow (current US$) in Sweden in 1999?
Your answer should be very brief. -2.68e+07. What is the difference between the Aid flow (current US$) of Norway in 1996 and the Aid flow (current US$) of Switzerland in 1999?
Offer a terse response. 1.84e+07. What is the difference between the Aid flow (current US$) of Portugal in 1996 and the Aid flow (current US$) of Sweden in 1999?
Provide a short and direct response. -4.45e+07. What is the difference between the Aid flow (current US$) of Portugal in 1996 and the Aid flow (current US$) of Switzerland in 1999?
Provide a succinct answer. 6.80e+05. What is the difference between the Aid flow (current US$) of Sweden in 1996 and the Aid flow (current US$) of Switzerland in 1999?
Offer a very short reply. 5.53e+07. What is the difference between the Aid flow (current US$) of Norway in 1997 and the Aid flow (current US$) of Portugal in 1998?
Your answer should be compact. 1.85e+07. What is the difference between the Aid flow (current US$) in Norway in 1997 and the Aid flow (current US$) in Sweden in 1998?
Your answer should be very brief. -3.58e+07. What is the difference between the Aid flow (current US$) of Norway in 1997 and the Aid flow (current US$) of Switzerland in 1998?
Make the answer very short. 1.91e+07. What is the difference between the Aid flow (current US$) in Portugal in 1997 and the Aid flow (current US$) in Sweden in 1998?
Make the answer very short. -5.49e+07. What is the difference between the Aid flow (current US$) of Portugal in 1997 and the Aid flow (current US$) of Switzerland in 1998?
Offer a terse response. -2.00e+04. What is the difference between the Aid flow (current US$) in Sweden in 1997 and the Aid flow (current US$) in Switzerland in 1998?
Give a very brief answer. 4.74e+07. What is the difference between the Aid flow (current US$) of Norway in 1997 and the Aid flow (current US$) of Portugal in 1999?
Offer a very short reply. 1.91e+07. What is the difference between the Aid flow (current US$) in Norway in 1997 and the Aid flow (current US$) in Sweden in 1999?
Offer a very short reply. -2.62e+07. What is the difference between the Aid flow (current US$) of Norway in 1997 and the Aid flow (current US$) of Switzerland in 1999?
Offer a terse response. 1.90e+07. What is the difference between the Aid flow (current US$) of Portugal in 1997 and the Aid flow (current US$) of Sweden in 1999?
Make the answer very short. -4.52e+07. What is the difference between the Aid flow (current US$) of Portugal in 1997 and the Aid flow (current US$) of Switzerland in 1999?
Your response must be concise. -4.00e+04. What is the difference between the Aid flow (current US$) in Sweden in 1997 and the Aid flow (current US$) in Switzerland in 1999?
Your response must be concise. 4.73e+07. What is the difference between the Aid flow (current US$) in Norway in 1998 and the Aid flow (current US$) in Portugal in 1999?
Give a very brief answer. 2.22e+07. What is the difference between the Aid flow (current US$) of Norway in 1998 and the Aid flow (current US$) of Sweden in 1999?
Your response must be concise. -2.30e+07. What is the difference between the Aid flow (current US$) in Norway in 1998 and the Aid flow (current US$) in Switzerland in 1999?
Your answer should be very brief. 2.22e+07. What is the difference between the Aid flow (current US$) in Portugal in 1998 and the Aid flow (current US$) in Sweden in 1999?
Give a very brief answer. -4.46e+07. What is the difference between the Aid flow (current US$) of Portugal in 1998 and the Aid flow (current US$) of Switzerland in 1999?
Your answer should be very brief. 5.70e+05. What is the difference between the Aid flow (current US$) of Sweden in 1998 and the Aid flow (current US$) of Switzerland in 1999?
Give a very brief answer. 5.48e+07. What is the average Aid flow (current US$) in Norway per year?
Ensure brevity in your answer.  2.21e+07. What is the average Aid flow (current US$) in Portugal per year?
Make the answer very short. 3.13e+05. What is the average Aid flow (current US$) in Sweden per year?
Ensure brevity in your answer.  6.22e+07. What is the average Aid flow (current US$) of Switzerland per year?
Give a very brief answer. 6.33e+04. In the year 1991, what is the difference between the Aid flow (current US$) of Norway and Aid flow (current US$) of Portugal?
Your response must be concise. 5.41e+06. In the year 1991, what is the difference between the Aid flow (current US$) of Norway and Aid flow (current US$) of Sweden?
Offer a terse response. 3.24e+06. In the year 1991, what is the difference between the Aid flow (current US$) in Norway and Aid flow (current US$) in Switzerland?
Offer a very short reply. 5.58e+06. In the year 1991, what is the difference between the Aid flow (current US$) of Portugal and Aid flow (current US$) of Sweden?
Your response must be concise. -2.17e+06. In the year 1991, what is the difference between the Aid flow (current US$) in Sweden and Aid flow (current US$) in Switzerland?
Provide a succinct answer. 2.34e+06. In the year 1992, what is the difference between the Aid flow (current US$) in Norway and Aid flow (current US$) in Portugal?
Make the answer very short. 4.14e+07. In the year 1992, what is the difference between the Aid flow (current US$) in Norway and Aid flow (current US$) in Sweden?
Provide a short and direct response. 2.79e+07. In the year 1992, what is the difference between the Aid flow (current US$) of Norway and Aid flow (current US$) of Switzerland?
Provide a succinct answer. 4.14e+07. In the year 1992, what is the difference between the Aid flow (current US$) of Portugal and Aid flow (current US$) of Sweden?
Offer a terse response. -1.34e+07. In the year 1992, what is the difference between the Aid flow (current US$) of Portugal and Aid flow (current US$) of Switzerland?
Provide a succinct answer. 5.00e+04. In the year 1992, what is the difference between the Aid flow (current US$) in Sweden and Aid flow (current US$) in Switzerland?
Your answer should be compact. 1.35e+07. In the year 1993, what is the difference between the Aid flow (current US$) of Norway and Aid flow (current US$) of Portugal?
Offer a terse response. 2.78e+07. In the year 1993, what is the difference between the Aid flow (current US$) of Norway and Aid flow (current US$) of Sweden?
Your answer should be compact. -2.30e+08. In the year 1993, what is the difference between the Aid flow (current US$) in Norway and Aid flow (current US$) in Switzerland?
Your answer should be very brief. 2.78e+07. In the year 1993, what is the difference between the Aid flow (current US$) in Portugal and Aid flow (current US$) in Sweden?
Your answer should be very brief. -2.57e+08. In the year 1993, what is the difference between the Aid flow (current US$) of Portugal and Aid flow (current US$) of Switzerland?
Your answer should be very brief. -2.00e+04. In the year 1993, what is the difference between the Aid flow (current US$) in Sweden and Aid flow (current US$) in Switzerland?
Your response must be concise. 2.57e+08. In the year 1994, what is the difference between the Aid flow (current US$) in Norway and Aid flow (current US$) in Portugal?
Provide a succinct answer. 4.02e+07. In the year 1994, what is the difference between the Aid flow (current US$) of Norway and Aid flow (current US$) of Sweden?
Provide a succinct answer. 2.00e+07. In the year 1994, what is the difference between the Aid flow (current US$) in Norway and Aid flow (current US$) in Switzerland?
Provide a succinct answer. 4.06e+07. In the year 1994, what is the difference between the Aid flow (current US$) in Portugal and Aid flow (current US$) in Sweden?
Ensure brevity in your answer.  -2.02e+07. In the year 1994, what is the difference between the Aid flow (current US$) of Portugal and Aid flow (current US$) of Switzerland?
Give a very brief answer. 4.20e+05. In the year 1994, what is the difference between the Aid flow (current US$) in Sweden and Aid flow (current US$) in Switzerland?
Provide a succinct answer. 2.06e+07. In the year 1995, what is the difference between the Aid flow (current US$) in Norway and Aid flow (current US$) in Portugal?
Provide a short and direct response. 1.48e+07. In the year 1995, what is the difference between the Aid flow (current US$) in Norway and Aid flow (current US$) in Sweden?
Your answer should be very brief. -4.72e+07. In the year 1995, what is the difference between the Aid flow (current US$) in Norway and Aid flow (current US$) in Switzerland?
Your answer should be very brief. 1.52e+07. In the year 1995, what is the difference between the Aid flow (current US$) of Portugal and Aid flow (current US$) of Sweden?
Offer a terse response. -6.20e+07. In the year 1995, what is the difference between the Aid flow (current US$) of Portugal and Aid flow (current US$) of Switzerland?
Ensure brevity in your answer.  3.80e+05. In the year 1995, what is the difference between the Aid flow (current US$) in Sweden and Aid flow (current US$) in Switzerland?
Offer a terse response. 6.24e+07. In the year 1996, what is the difference between the Aid flow (current US$) in Norway and Aid flow (current US$) in Portugal?
Offer a terse response. 1.77e+07. In the year 1996, what is the difference between the Aid flow (current US$) of Norway and Aid flow (current US$) of Sweden?
Provide a short and direct response. -3.69e+07. In the year 1996, what is the difference between the Aid flow (current US$) of Norway and Aid flow (current US$) of Switzerland?
Give a very brief answer. 1.84e+07. In the year 1996, what is the difference between the Aid flow (current US$) of Portugal and Aid flow (current US$) of Sweden?
Provide a short and direct response. -5.46e+07. In the year 1996, what is the difference between the Aid flow (current US$) of Portugal and Aid flow (current US$) of Switzerland?
Your response must be concise. 7.10e+05. In the year 1996, what is the difference between the Aid flow (current US$) in Sweden and Aid flow (current US$) in Switzerland?
Keep it short and to the point. 5.53e+07. In the year 1997, what is the difference between the Aid flow (current US$) of Norway and Aid flow (current US$) of Portugal?
Keep it short and to the point. 1.91e+07. In the year 1997, what is the difference between the Aid flow (current US$) of Norway and Aid flow (current US$) of Sweden?
Keep it short and to the point. -2.83e+07. In the year 1997, what is the difference between the Aid flow (current US$) in Norway and Aid flow (current US$) in Switzerland?
Provide a short and direct response. 1.91e+07. In the year 1997, what is the difference between the Aid flow (current US$) of Portugal and Aid flow (current US$) of Sweden?
Provide a short and direct response. -4.74e+07. In the year 1997, what is the difference between the Aid flow (current US$) of Sweden and Aid flow (current US$) of Switzerland?
Ensure brevity in your answer.  4.74e+07. In the year 1998, what is the difference between the Aid flow (current US$) in Norway and Aid flow (current US$) in Portugal?
Keep it short and to the point. 2.16e+07. In the year 1998, what is the difference between the Aid flow (current US$) of Norway and Aid flow (current US$) of Sweden?
Make the answer very short. -3.26e+07. In the year 1998, what is the difference between the Aid flow (current US$) of Norway and Aid flow (current US$) of Switzerland?
Make the answer very short. 2.22e+07. In the year 1998, what is the difference between the Aid flow (current US$) in Portugal and Aid flow (current US$) in Sweden?
Offer a very short reply. -5.43e+07. In the year 1998, what is the difference between the Aid flow (current US$) in Portugal and Aid flow (current US$) in Switzerland?
Your answer should be compact. 5.90e+05. In the year 1998, what is the difference between the Aid flow (current US$) in Sweden and Aid flow (current US$) in Switzerland?
Your answer should be very brief. 5.49e+07. In the year 1999, what is the difference between the Aid flow (current US$) in Norway and Aid flow (current US$) in Portugal?
Your answer should be compact. 7.71e+06. In the year 1999, what is the difference between the Aid flow (current US$) of Norway and Aid flow (current US$) of Sweden?
Your answer should be compact. -3.75e+07. In the year 1999, what is the difference between the Aid flow (current US$) in Norway and Aid flow (current US$) in Switzerland?
Make the answer very short. 7.67e+06. In the year 1999, what is the difference between the Aid flow (current US$) of Portugal and Aid flow (current US$) of Sweden?
Your answer should be very brief. -4.52e+07. In the year 1999, what is the difference between the Aid flow (current US$) in Portugal and Aid flow (current US$) in Switzerland?
Your response must be concise. -4.00e+04. In the year 1999, what is the difference between the Aid flow (current US$) of Sweden and Aid flow (current US$) of Switzerland?
Make the answer very short. 4.52e+07. What is the ratio of the Aid flow (current US$) in Norway in 1991 to that in 1992?
Ensure brevity in your answer.  0.14. What is the ratio of the Aid flow (current US$) of Portugal in 1991 to that in 1992?
Ensure brevity in your answer.  2. What is the ratio of the Aid flow (current US$) in Sweden in 1991 to that in 1992?
Your answer should be compact. 0.18. What is the ratio of the Aid flow (current US$) of Norway in 1991 to that in 1993?
Provide a short and direct response. 0.2. What is the ratio of the Aid flow (current US$) of Sweden in 1991 to that in 1993?
Keep it short and to the point. 0.01. What is the ratio of the Aid flow (current US$) in Switzerland in 1991 to that in 1993?
Offer a very short reply. 1.17. What is the ratio of the Aid flow (current US$) in Norway in 1991 to that in 1994?
Your response must be concise. 0.14. What is the ratio of the Aid flow (current US$) of Portugal in 1991 to that in 1994?
Your answer should be very brief. 0.51. What is the ratio of the Aid flow (current US$) of Sweden in 1991 to that in 1994?
Give a very brief answer. 0.12. What is the ratio of the Aid flow (current US$) in Switzerland in 1991 to that in 1994?
Provide a short and direct response. 1.4. What is the ratio of the Aid flow (current US$) in Norway in 1991 to that in 1995?
Ensure brevity in your answer.  0.37. What is the ratio of the Aid flow (current US$) of Portugal in 1991 to that in 1995?
Offer a very short reply. 0.57. What is the ratio of the Aid flow (current US$) in Sweden in 1991 to that in 1995?
Provide a short and direct response. 0.04. What is the ratio of the Aid flow (current US$) of Switzerland in 1991 to that in 1995?
Your answer should be very brief. 1.75. What is the ratio of the Aid flow (current US$) in Norway in 1991 to that in 1996?
Your answer should be very brief. 0.31. What is the ratio of the Aid flow (current US$) in Portugal in 1991 to that in 1996?
Your response must be concise. 0.31. What is the ratio of the Aid flow (current US$) in Sweden in 1991 to that in 1996?
Your answer should be very brief. 0.04. What is the ratio of the Aid flow (current US$) of Norway in 1991 to that in 1997?
Provide a short and direct response. 0.3. What is the ratio of the Aid flow (current US$) of Sweden in 1991 to that in 1997?
Make the answer very short. 0.05. What is the ratio of the Aid flow (current US$) of Norway in 1991 to that in 1998?
Provide a short and direct response. 0.25. What is the ratio of the Aid flow (current US$) in Portugal in 1991 to that in 1998?
Offer a very short reply. 0.36. What is the ratio of the Aid flow (current US$) in Sweden in 1991 to that in 1998?
Ensure brevity in your answer.  0.04. What is the ratio of the Aid flow (current US$) of Switzerland in 1991 to that in 1998?
Your answer should be very brief. 1. What is the ratio of the Aid flow (current US$) in Norway in 1991 to that in 1999?
Keep it short and to the point. 0.73. What is the ratio of the Aid flow (current US$) of Sweden in 1991 to that in 1999?
Ensure brevity in your answer.  0.05. What is the ratio of the Aid flow (current US$) of Norway in 1992 to that in 1993?
Provide a short and direct response. 1.49. What is the ratio of the Aid flow (current US$) in Portugal in 1992 to that in 1993?
Offer a very short reply. 3. What is the ratio of the Aid flow (current US$) in Sweden in 1992 to that in 1993?
Keep it short and to the point. 0.05. What is the ratio of the Aid flow (current US$) in Switzerland in 1992 to that in 1993?
Your response must be concise. 1.17. What is the ratio of the Aid flow (current US$) in Norway in 1992 to that in 1994?
Make the answer very short. 1.02. What is the ratio of the Aid flow (current US$) of Portugal in 1992 to that in 1994?
Keep it short and to the point. 0.26. What is the ratio of the Aid flow (current US$) of Sweden in 1992 to that in 1994?
Offer a terse response. 0.66. What is the ratio of the Aid flow (current US$) of Switzerland in 1992 to that in 1994?
Make the answer very short. 1.4. What is the ratio of the Aid flow (current US$) of Norway in 1992 to that in 1995?
Provide a succinct answer. 2.73. What is the ratio of the Aid flow (current US$) of Portugal in 1992 to that in 1995?
Your answer should be compact. 0.29. What is the ratio of the Aid flow (current US$) in Sweden in 1992 to that in 1995?
Ensure brevity in your answer.  0.22. What is the ratio of the Aid flow (current US$) of Norway in 1992 to that in 1996?
Your answer should be very brief. 2.24. What is the ratio of the Aid flow (current US$) of Portugal in 1992 to that in 1996?
Ensure brevity in your answer.  0.16. What is the ratio of the Aid flow (current US$) in Sweden in 1992 to that in 1996?
Ensure brevity in your answer.  0.24. What is the ratio of the Aid flow (current US$) of Switzerland in 1992 to that in 1996?
Your answer should be very brief. 1.17. What is the ratio of the Aid flow (current US$) in Norway in 1992 to that in 1997?
Your answer should be very brief. 2.17. What is the ratio of the Aid flow (current US$) in Portugal in 1992 to that in 1997?
Your response must be concise. 2.4. What is the ratio of the Aid flow (current US$) of Sweden in 1992 to that in 1997?
Your answer should be very brief. 0.29. What is the ratio of the Aid flow (current US$) of Switzerland in 1992 to that in 1997?
Make the answer very short. 1.17. What is the ratio of the Aid flow (current US$) in Norway in 1992 to that in 1998?
Make the answer very short. 1.86. What is the ratio of the Aid flow (current US$) in Portugal in 1992 to that in 1998?
Your answer should be compact. 0.18. What is the ratio of the Aid flow (current US$) of Sweden in 1992 to that in 1998?
Give a very brief answer. 0.25. What is the ratio of the Aid flow (current US$) in Switzerland in 1992 to that in 1998?
Your response must be concise. 1. What is the ratio of the Aid flow (current US$) in Norway in 1992 to that in 1999?
Give a very brief answer. 5.34. What is the ratio of the Aid flow (current US$) in Sweden in 1992 to that in 1999?
Your answer should be compact. 0.3. What is the ratio of the Aid flow (current US$) of Norway in 1993 to that in 1994?
Your answer should be very brief. 0.69. What is the ratio of the Aid flow (current US$) of Portugal in 1993 to that in 1994?
Keep it short and to the point. 0.09. What is the ratio of the Aid flow (current US$) of Sweden in 1993 to that in 1994?
Make the answer very short. 12.46. What is the ratio of the Aid flow (current US$) of Switzerland in 1993 to that in 1994?
Your response must be concise. 1.2. What is the ratio of the Aid flow (current US$) in Norway in 1993 to that in 1995?
Your answer should be compact. 1.83. What is the ratio of the Aid flow (current US$) of Portugal in 1993 to that in 1995?
Your response must be concise. 0.1. What is the ratio of the Aid flow (current US$) in Sweden in 1993 to that in 1995?
Provide a succinct answer. 4.13. What is the ratio of the Aid flow (current US$) of Switzerland in 1993 to that in 1995?
Give a very brief answer. 1.5. What is the ratio of the Aid flow (current US$) in Norway in 1993 to that in 1996?
Your answer should be compact. 1.51. What is the ratio of the Aid flow (current US$) in Portugal in 1993 to that in 1996?
Your answer should be compact. 0.05. What is the ratio of the Aid flow (current US$) in Sweden in 1993 to that in 1996?
Provide a short and direct response. 4.65. What is the ratio of the Aid flow (current US$) of Switzerland in 1993 to that in 1996?
Your response must be concise. 1. What is the ratio of the Aid flow (current US$) in Norway in 1993 to that in 1997?
Your response must be concise. 1.46. What is the ratio of the Aid flow (current US$) in Portugal in 1993 to that in 1997?
Your response must be concise. 0.8. What is the ratio of the Aid flow (current US$) of Sweden in 1993 to that in 1997?
Your response must be concise. 5.43. What is the ratio of the Aid flow (current US$) in Switzerland in 1993 to that in 1997?
Your answer should be very brief. 1. What is the ratio of the Aid flow (current US$) in Norway in 1993 to that in 1998?
Your answer should be very brief. 1.25. What is the ratio of the Aid flow (current US$) of Portugal in 1993 to that in 1998?
Your answer should be very brief. 0.06. What is the ratio of the Aid flow (current US$) of Sweden in 1993 to that in 1998?
Keep it short and to the point. 4.69. What is the ratio of the Aid flow (current US$) of Switzerland in 1993 to that in 1998?
Your response must be concise. 0.86. What is the ratio of the Aid flow (current US$) in Norway in 1993 to that in 1999?
Provide a succinct answer. 3.59. What is the ratio of the Aid flow (current US$) of Sweden in 1993 to that in 1999?
Make the answer very short. 5.68. What is the ratio of the Aid flow (current US$) of Switzerland in 1993 to that in 1999?
Make the answer very short. 0.67. What is the ratio of the Aid flow (current US$) in Norway in 1994 to that in 1995?
Your response must be concise. 2.67. What is the ratio of the Aid flow (current US$) of Portugal in 1994 to that in 1995?
Provide a succinct answer. 1.12. What is the ratio of the Aid flow (current US$) of Sweden in 1994 to that in 1995?
Keep it short and to the point. 0.33. What is the ratio of the Aid flow (current US$) in Switzerland in 1994 to that in 1995?
Keep it short and to the point. 1.25. What is the ratio of the Aid flow (current US$) in Norway in 1994 to that in 1996?
Your answer should be compact. 2.2. What is the ratio of the Aid flow (current US$) in Portugal in 1994 to that in 1996?
Your answer should be compact. 0.61. What is the ratio of the Aid flow (current US$) in Sweden in 1994 to that in 1996?
Offer a terse response. 0.37. What is the ratio of the Aid flow (current US$) in Switzerland in 1994 to that in 1996?
Make the answer very short. 0.83. What is the ratio of the Aid flow (current US$) in Norway in 1994 to that in 1997?
Provide a succinct answer. 2.12. What is the ratio of the Aid flow (current US$) of Portugal in 1994 to that in 1997?
Offer a terse response. 9.4. What is the ratio of the Aid flow (current US$) of Sweden in 1994 to that in 1997?
Make the answer very short. 0.44. What is the ratio of the Aid flow (current US$) of Norway in 1994 to that in 1998?
Your response must be concise. 1.83. What is the ratio of the Aid flow (current US$) of Portugal in 1994 to that in 1998?
Give a very brief answer. 0.71. What is the ratio of the Aid flow (current US$) in Sweden in 1994 to that in 1998?
Make the answer very short. 0.38. What is the ratio of the Aid flow (current US$) of Norway in 1994 to that in 1999?
Make the answer very short. 5.24. What is the ratio of the Aid flow (current US$) of Portugal in 1994 to that in 1999?
Offer a terse response. 9.4. What is the ratio of the Aid flow (current US$) in Sweden in 1994 to that in 1999?
Provide a succinct answer. 0.46. What is the ratio of the Aid flow (current US$) in Switzerland in 1994 to that in 1999?
Provide a succinct answer. 0.56. What is the ratio of the Aid flow (current US$) of Norway in 1995 to that in 1996?
Keep it short and to the point. 0.82. What is the ratio of the Aid flow (current US$) of Portugal in 1995 to that in 1996?
Make the answer very short. 0.55. What is the ratio of the Aid flow (current US$) in Sweden in 1995 to that in 1996?
Your response must be concise. 1.13. What is the ratio of the Aid flow (current US$) in Switzerland in 1995 to that in 1996?
Offer a very short reply. 0.67. What is the ratio of the Aid flow (current US$) of Norway in 1995 to that in 1997?
Keep it short and to the point. 0.79. What is the ratio of the Aid flow (current US$) of Sweden in 1995 to that in 1997?
Make the answer very short. 1.32. What is the ratio of the Aid flow (current US$) in Switzerland in 1995 to that in 1997?
Ensure brevity in your answer.  0.67. What is the ratio of the Aid flow (current US$) in Norway in 1995 to that in 1998?
Give a very brief answer. 0.68. What is the ratio of the Aid flow (current US$) of Portugal in 1995 to that in 1998?
Make the answer very short. 0.64. What is the ratio of the Aid flow (current US$) in Sweden in 1995 to that in 1998?
Give a very brief answer. 1.14. What is the ratio of the Aid flow (current US$) of Norway in 1995 to that in 1999?
Your answer should be compact. 1.96. What is the ratio of the Aid flow (current US$) in Portugal in 1995 to that in 1999?
Provide a short and direct response. 8.4. What is the ratio of the Aid flow (current US$) of Sweden in 1995 to that in 1999?
Provide a short and direct response. 1.38. What is the ratio of the Aid flow (current US$) of Switzerland in 1995 to that in 1999?
Your answer should be compact. 0.44. What is the ratio of the Aid flow (current US$) in Norway in 1996 to that in 1997?
Offer a very short reply. 0.97. What is the ratio of the Aid flow (current US$) of Portugal in 1996 to that in 1997?
Offer a terse response. 15.4. What is the ratio of the Aid flow (current US$) of Sweden in 1996 to that in 1997?
Offer a very short reply. 1.17. What is the ratio of the Aid flow (current US$) in Norway in 1996 to that in 1998?
Provide a succinct answer. 0.83. What is the ratio of the Aid flow (current US$) of Switzerland in 1996 to that in 1998?
Your answer should be very brief. 0.86. What is the ratio of the Aid flow (current US$) of Norway in 1996 to that in 1999?
Provide a short and direct response. 2.39. What is the ratio of the Aid flow (current US$) in Sweden in 1996 to that in 1999?
Ensure brevity in your answer.  1.22. What is the ratio of the Aid flow (current US$) of Norway in 1997 to that in 1998?
Keep it short and to the point. 0.86. What is the ratio of the Aid flow (current US$) in Portugal in 1997 to that in 1998?
Provide a short and direct response. 0.08. What is the ratio of the Aid flow (current US$) of Sweden in 1997 to that in 1998?
Your answer should be very brief. 0.86. What is the ratio of the Aid flow (current US$) in Switzerland in 1997 to that in 1998?
Give a very brief answer. 0.86. What is the ratio of the Aid flow (current US$) in Norway in 1997 to that in 1999?
Make the answer very short. 2.47. What is the ratio of the Aid flow (current US$) in Sweden in 1997 to that in 1999?
Provide a short and direct response. 1.05. What is the ratio of the Aid flow (current US$) of Switzerland in 1997 to that in 1999?
Your answer should be compact. 0.67. What is the ratio of the Aid flow (current US$) of Norway in 1998 to that in 1999?
Offer a very short reply. 2.87. What is the ratio of the Aid flow (current US$) of Portugal in 1998 to that in 1999?
Keep it short and to the point. 13.2. What is the ratio of the Aid flow (current US$) in Sweden in 1998 to that in 1999?
Keep it short and to the point. 1.21. What is the difference between the highest and the second highest Aid flow (current US$) of Portugal?
Offer a very short reply. 1.10e+05. What is the difference between the highest and the second highest Aid flow (current US$) in Sweden?
Ensure brevity in your answer.  1.95e+08. What is the difference between the highest and the second highest Aid flow (current US$) of Switzerland?
Ensure brevity in your answer.  2.00e+04. What is the difference between the highest and the lowest Aid flow (current US$) in Norway?
Provide a succinct answer. 3.58e+07. What is the difference between the highest and the lowest Aid flow (current US$) in Portugal?
Make the answer very short. 7.30e+05. What is the difference between the highest and the lowest Aid flow (current US$) in Sweden?
Your response must be concise. 2.55e+08. What is the difference between the highest and the lowest Aid flow (current US$) in Switzerland?
Your answer should be compact. 5.00e+04. 